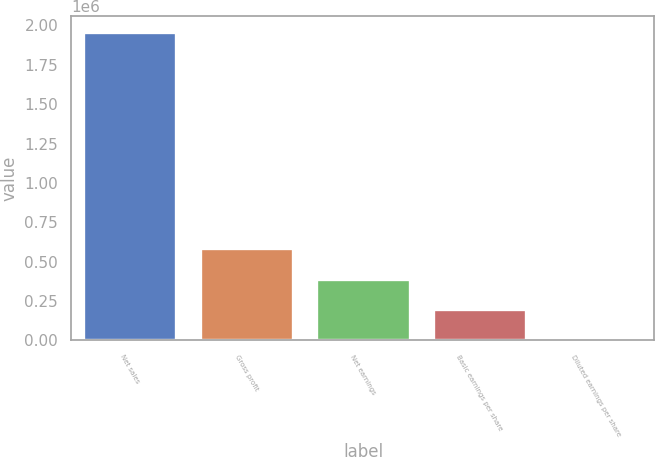Convert chart to OTSL. <chart><loc_0><loc_0><loc_500><loc_500><bar_chart><fcel>Net sales<fcel>Gross profit<fcel>Net earnings<fcel>Basic earnings per share<fcel>Diluted earnings per share<nl><fcel>1.96154e+06<fcel>588462<fcel>392309<fcel>196155<fcel>1.63<nl></chart> 